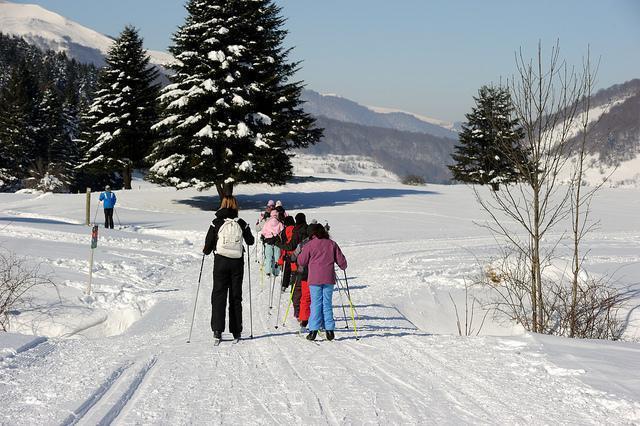What kind of terrain is best for this activity?
Indicate the correct response and explain using: 'Answer: answer
Rationale: rationale.'
Options: Downhill, rocky, flat, uphill. Answer: flat.
Rationale: The terrain is flat. 